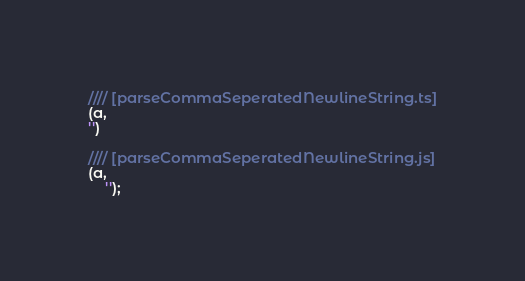<code> <loc_0><loc_0><loc_500><loc_500><_JavaScript_>//// [parseCommaSeperatedNewlineString.ts]
(a,
'')

//// [parseCommaSeperatedNewlineString.js]
(a,
    '');
</code> 